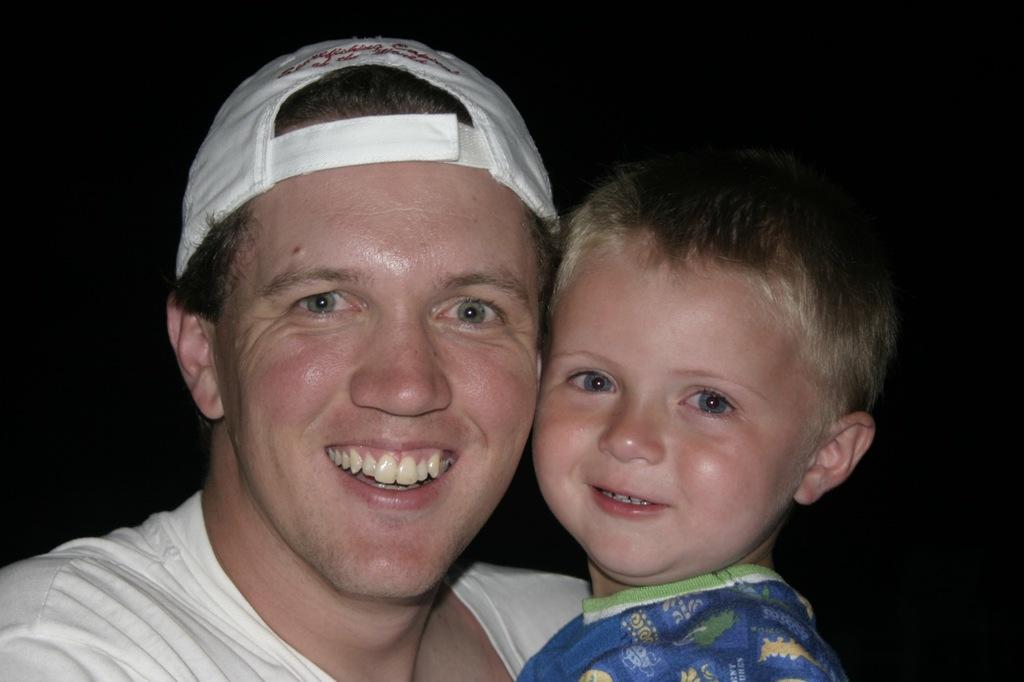Who is present in the image? There is a man and a boy in the image. What is the man wearing in the image? The man is wearing a white t-shirt and a cap. What is the boy wearing in the image? The boy is wearing a blue t-shirt. What type of pen is the man using to write an example in the image? There is no pen or writing activity present in the image. 